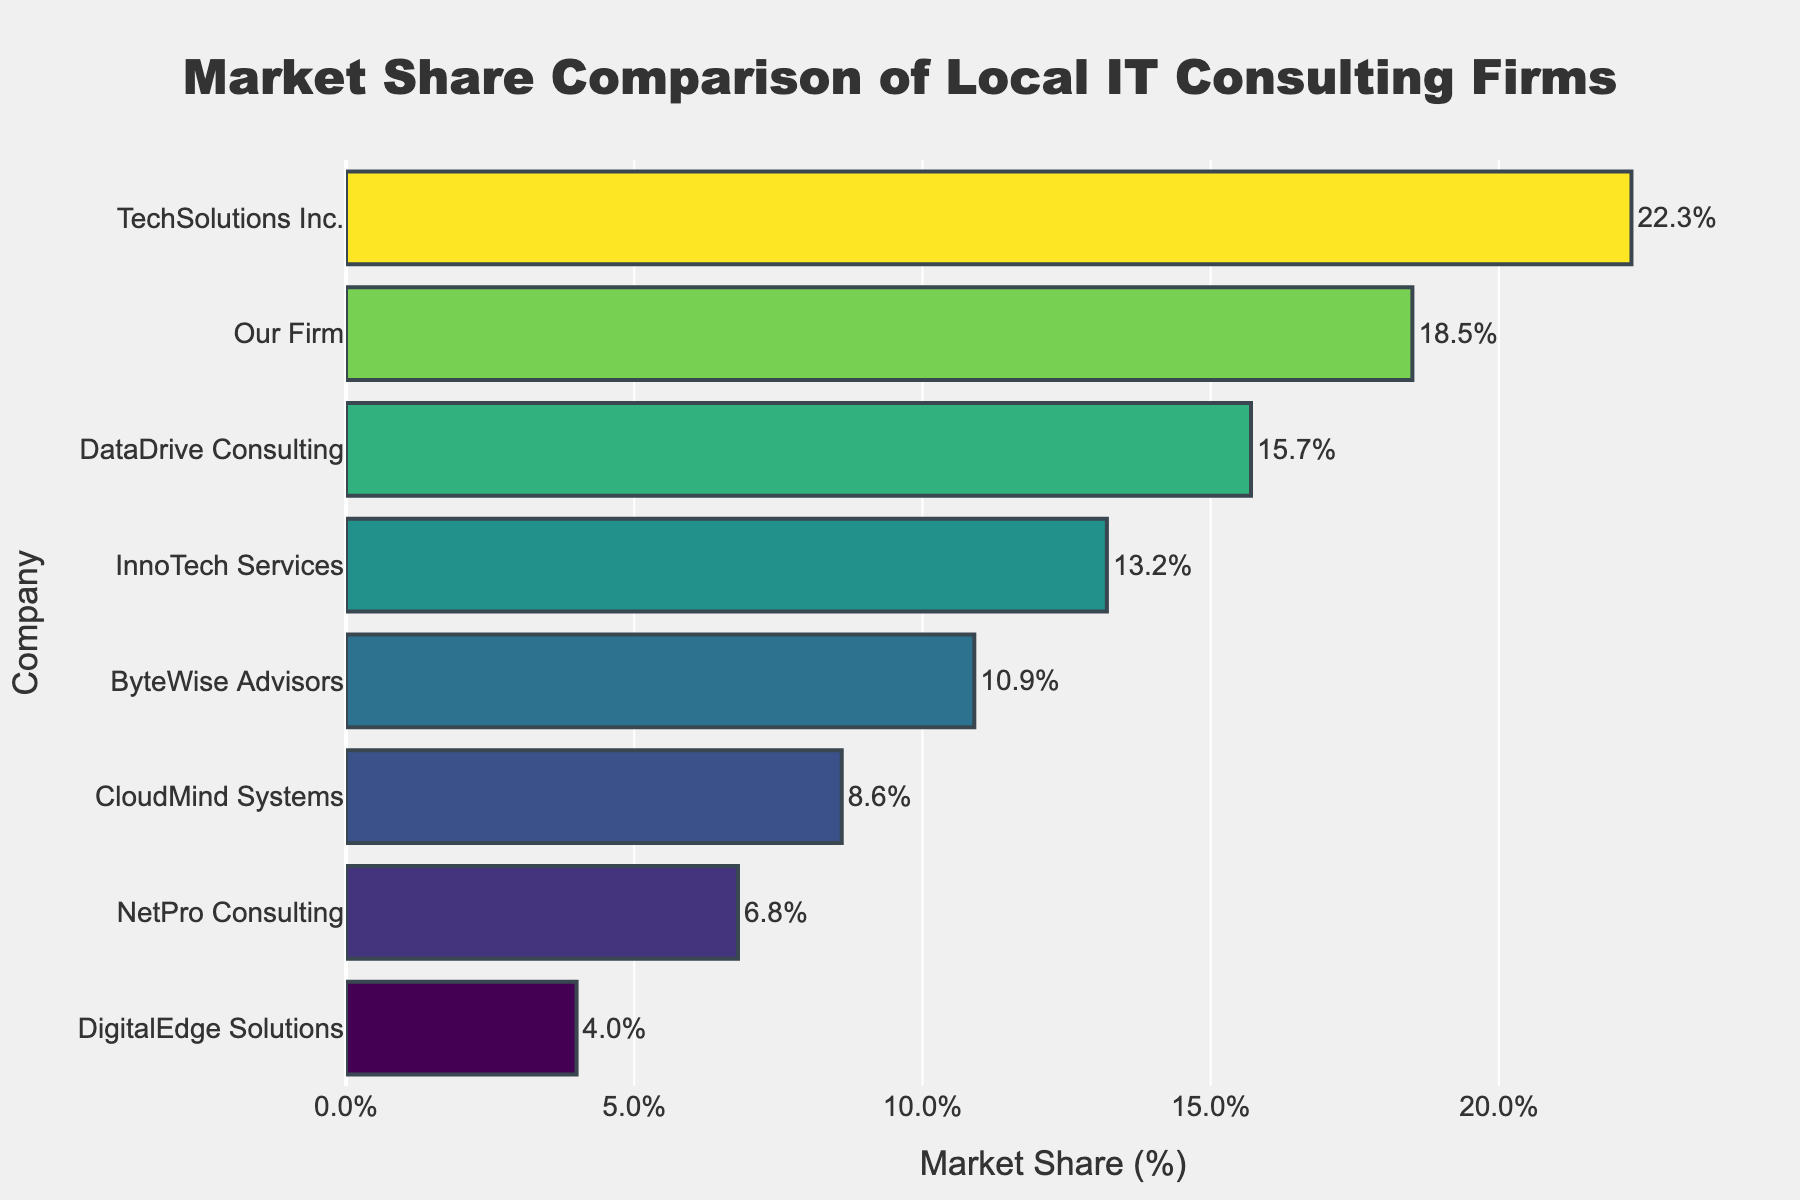Which company has the highest market share? Look at the bar that extends the furthest to the right in the chart. The label associated with this bar represents the company with the highest market share.
Answer: TechSolutions Inc Which company has the lowest market share? Identify the bar that extends the least to the right. The label next to this bar will be the company with the lowest market share.
Answer: DigitalEdge Solutions By how much does TechSolutions Inc.'s market share exceed our firm's market share? Find the market share values for TechSolutions Inc. (22.3%) and our firm (18.5%). Subtract our firm's value from TechSolutions Inc.'s value: 22.3 - 18.5.
Answer: 3.8% How much market share do InnoTech Services and ByteWise Advisors have combined? Find the market share values for InnoTech Services (13.2%) and ByteWise Advisors (10.9%). Add these values together: 13.2 + 10.9.
Answer: 24.1% What is the average market share of DataDrive Consulting and CloudMind Systems? Find the market share values for DataDrive Consulting (15.7%) and CloudMind Systems (8.6%). Add these values together and divide by 2: (15.7 + 8.6) / 2.
Answer: 12.15% Which company has a higher market share: InnoTech Services or NetPro Consulting? Compare the market share value of InnoTech Services (13.2%) with that of NetPro Consulting (6.8%).
Answer: InnoTech Services How many companies have a market share greater than 10%? Locate and count the companies with bars extending beyond the 10% mark on the x-axis.
Answer: 5 What is the difference in market share between ByteWise Advisors and DigitalEdge Solutions? Subtract the market share value of DigitalEdge Solutions (4.0%) from that of ByteWise Advisors (10.9%): 10.9 - 4.0.
Answer: 6.9% What is the total market share of the top three companies? Identify the top three companies based on the lengths of their bars (TechSolutions Inc., Our Firm, DataDrive Consulting). Sum their market shares: 22.3 + 18.5 + 15.7.
Answer: 56.5% Which company has a market share closest to the average market share of all firms? Calculate the average market share of all companies first. Sum all market share values: 100%. There are 8 companies, so the average is 100% / 8 = 12.5%. Find the company with a market share closest to this average, which is InnoTech Services with 13.2%.
Answer: InnoTech Services 